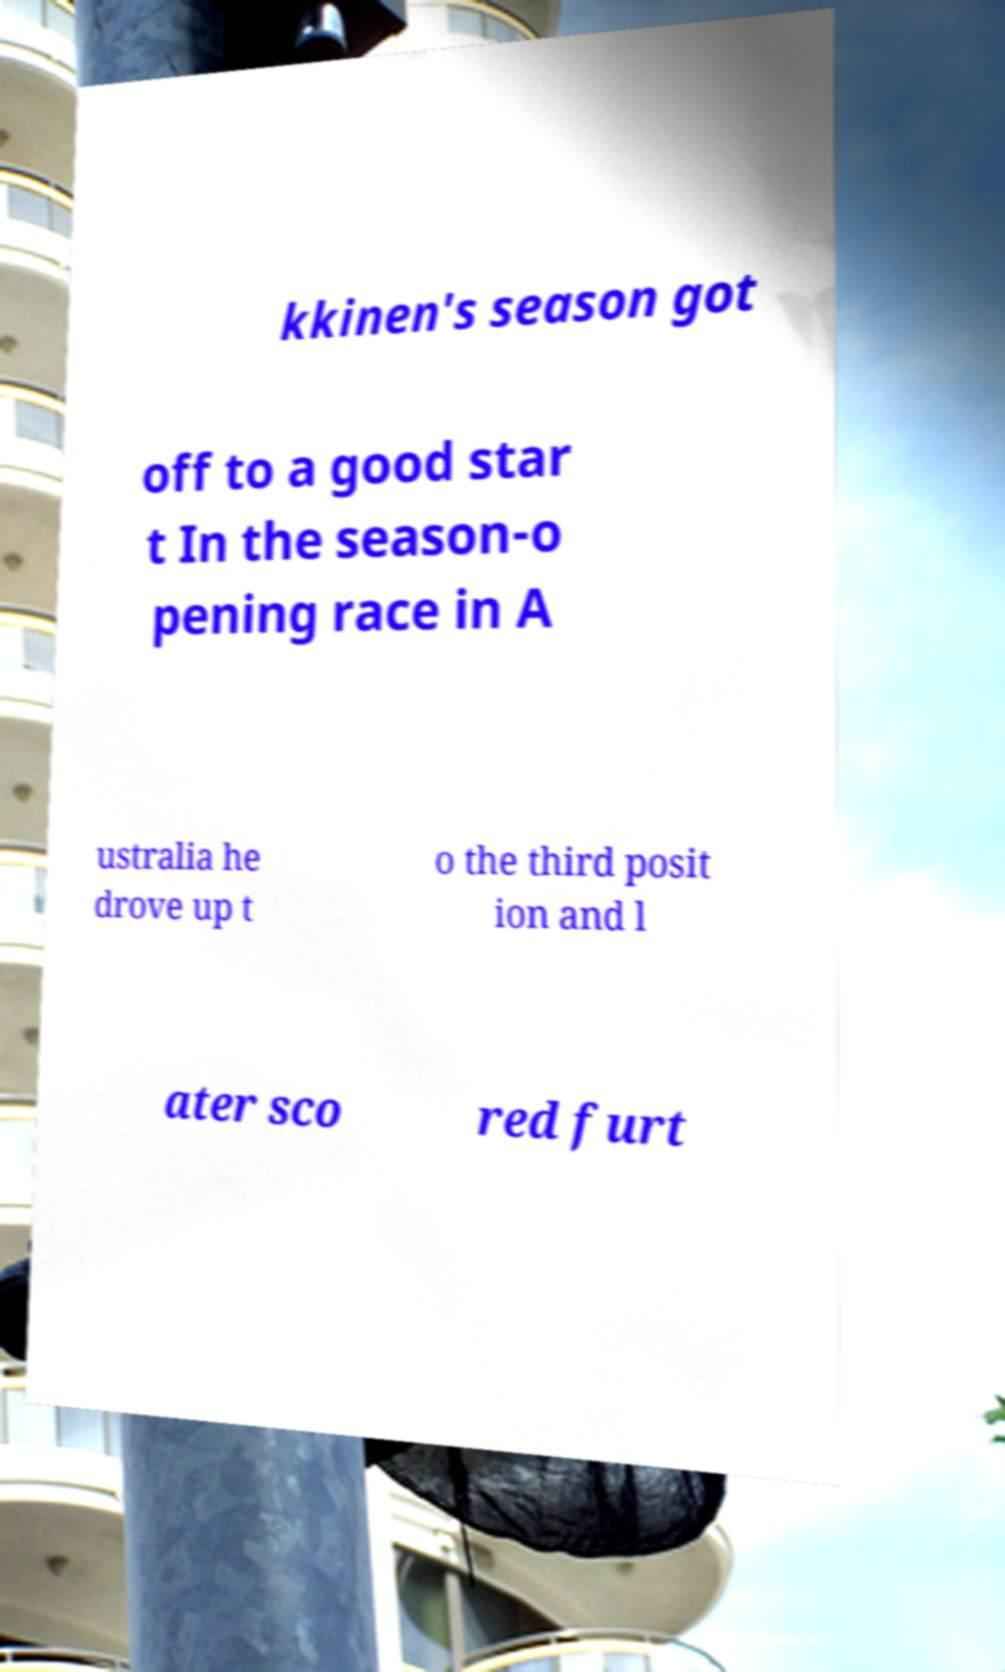Could you assist in decoding the text presented in this image and type it out clearly? kkinen's season got off to a good star t In the season-o pening race in A ustralia he drove up t o the third posit ion and l ater sco red furt 